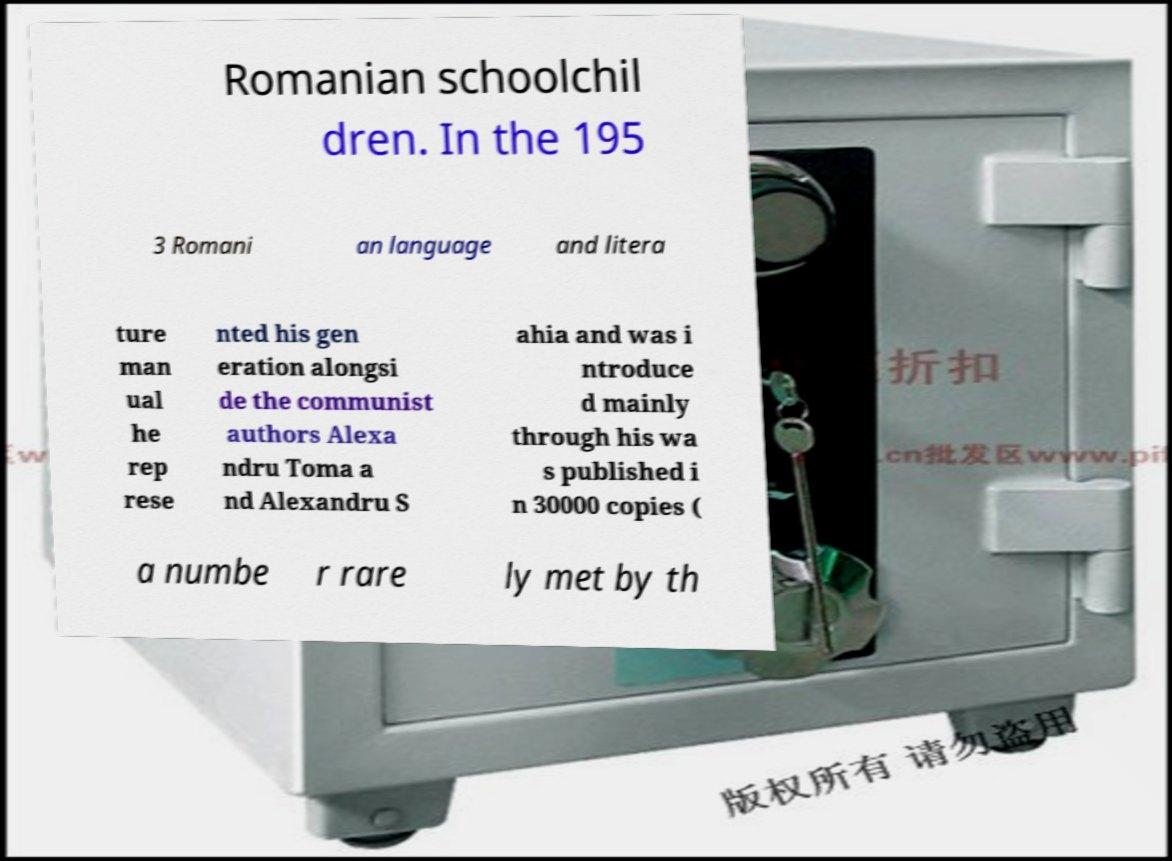Please identify and transcribe the text found in this image. Romanian schoolchil dren. In the 195 3 Romani an language and litera ture man ual he rep rese nted his gen eration alongsi de the communist authors Alexa ndru Toma a nd Alexandru S ahia and was i ntroduce d mainly through his wa s published i n 30000 copies ( a numbe r rare ly met by th 